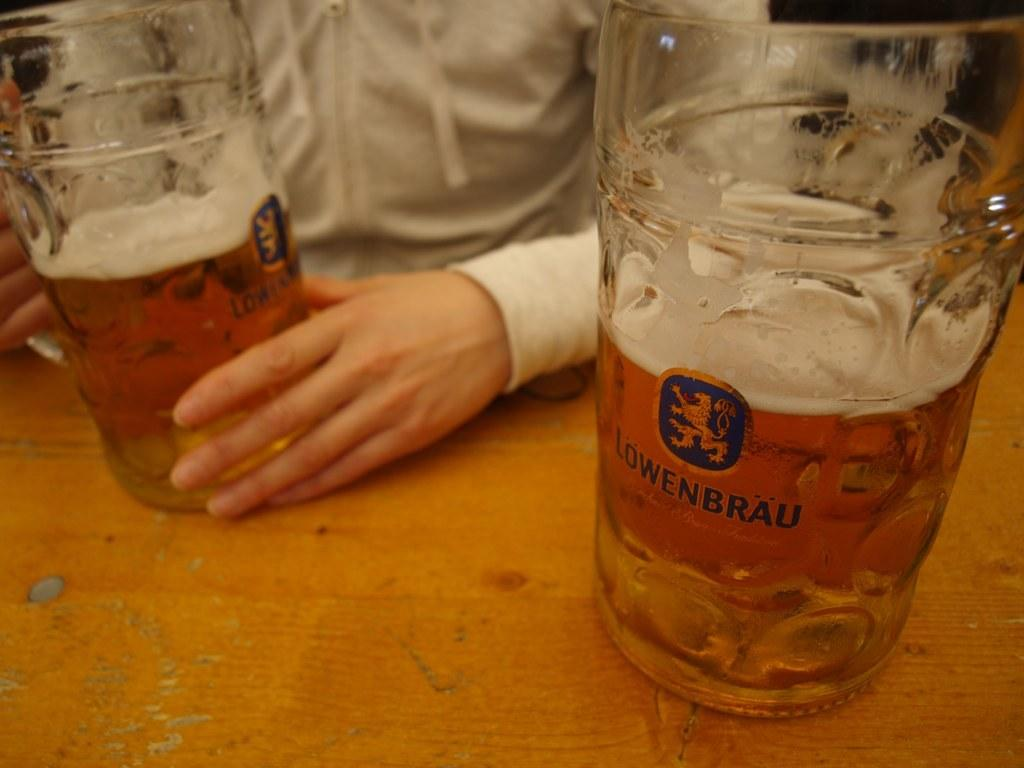Provide a one-sentence caption for the provided image. a large mug with lawenbrau beer in it is on a table. 